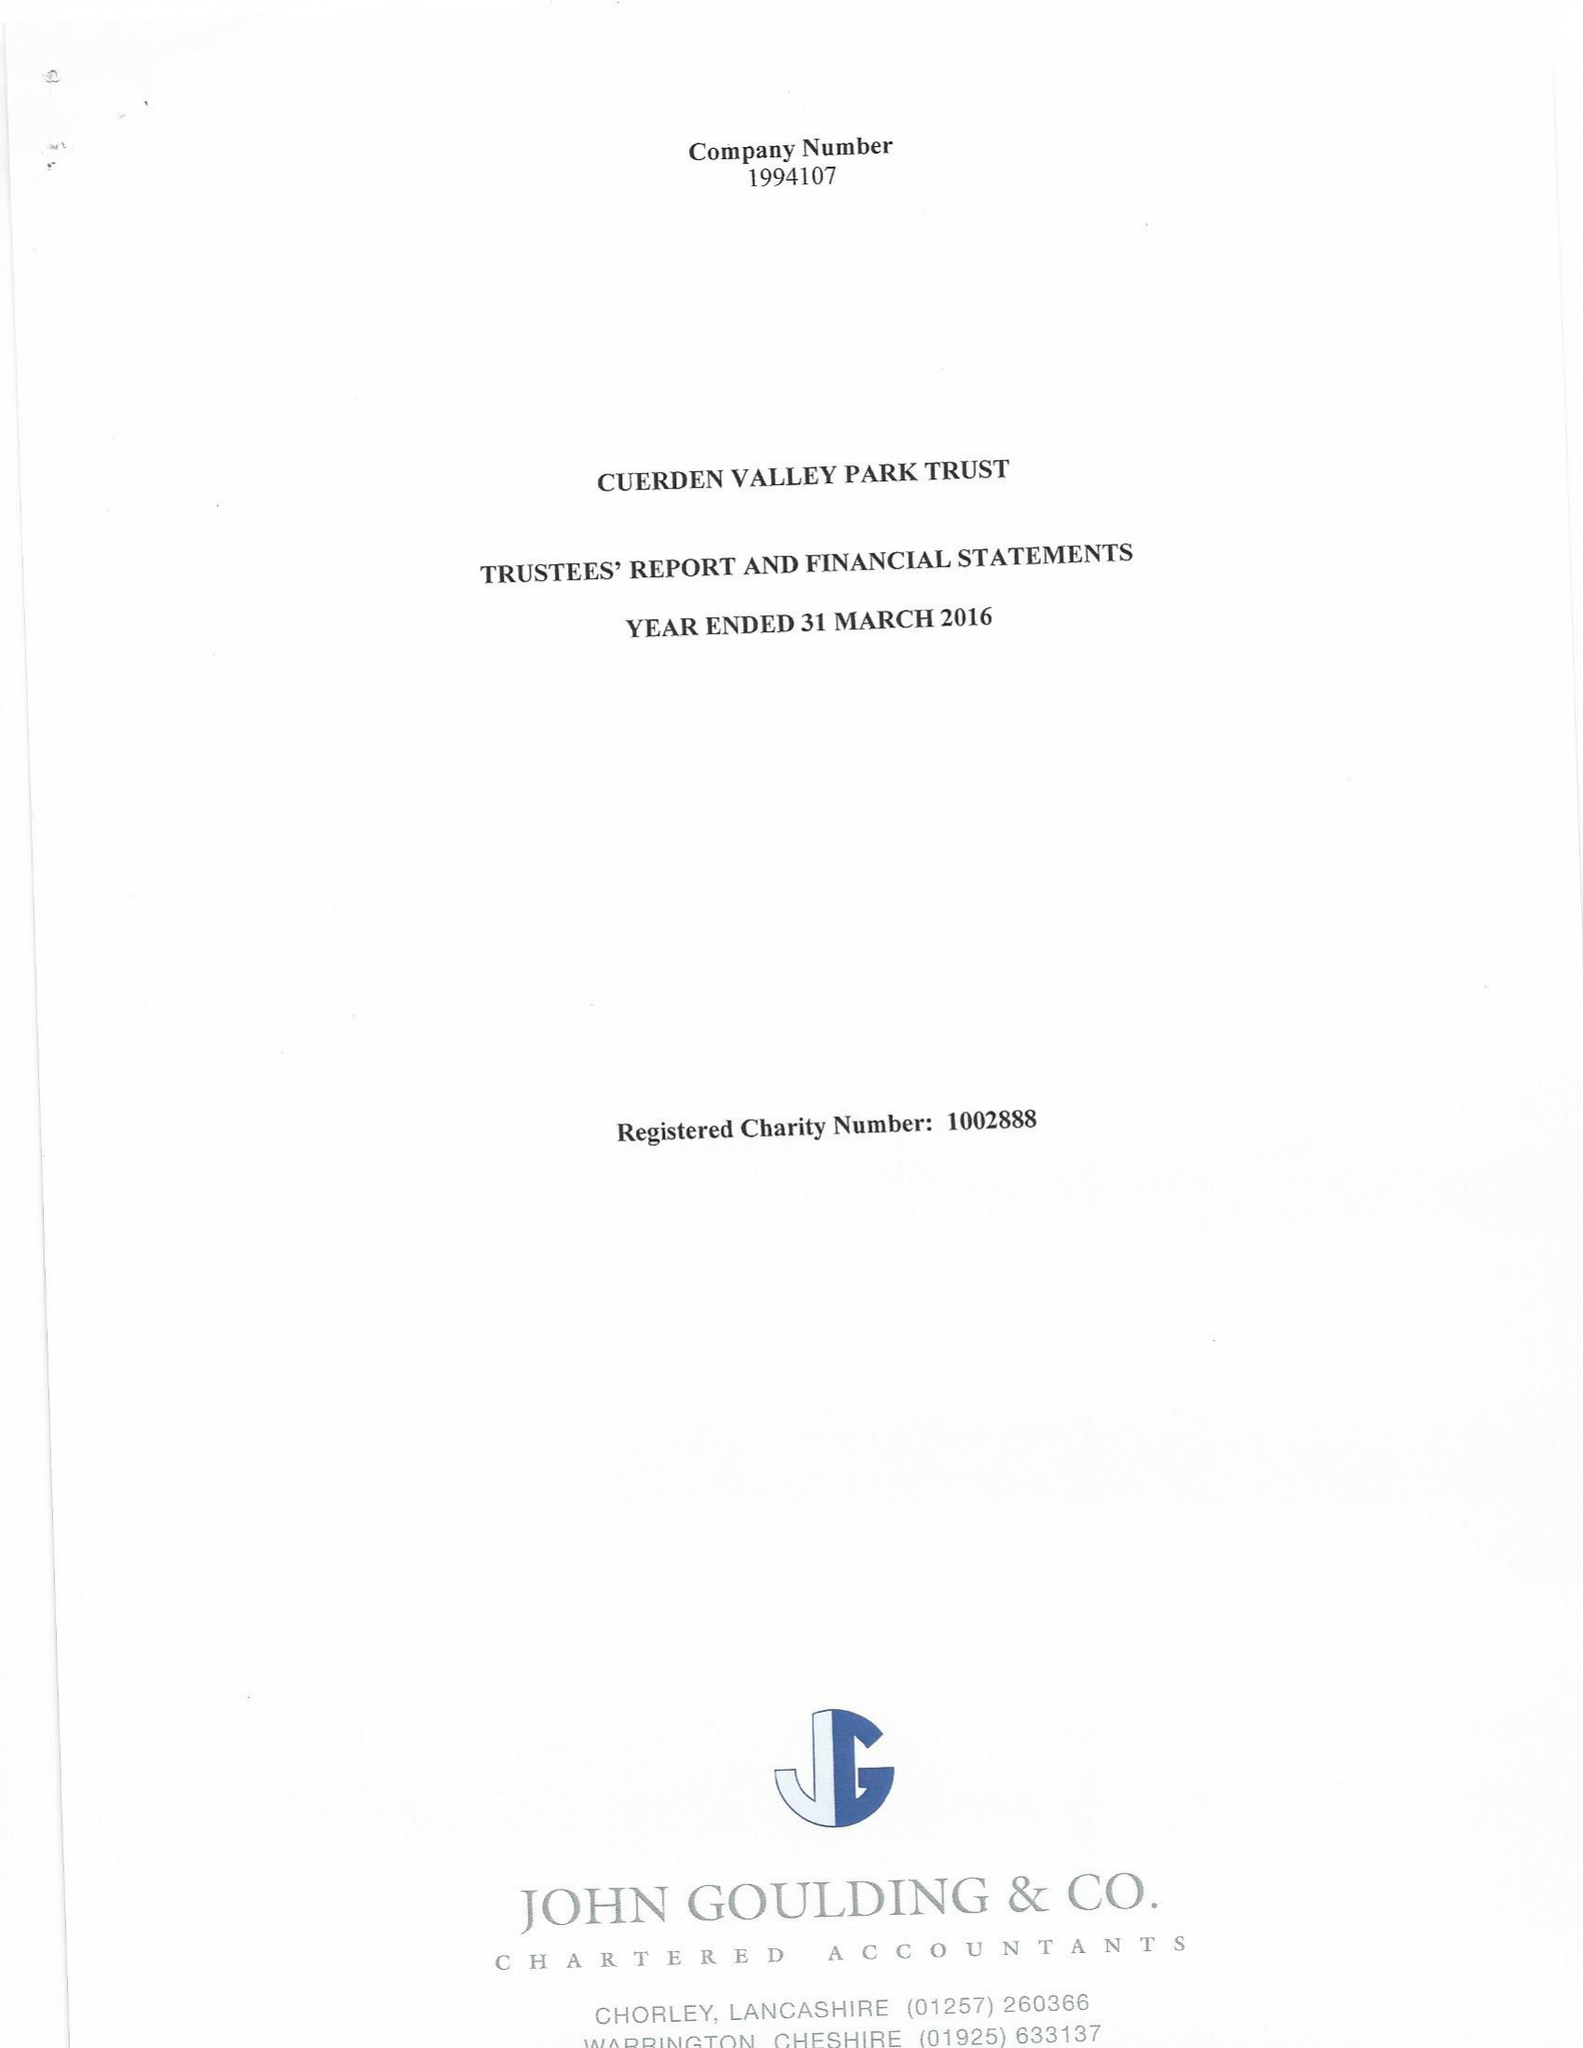What is the value for the report_date?
Answer the question using a single word or phrase. 2016-03-31 